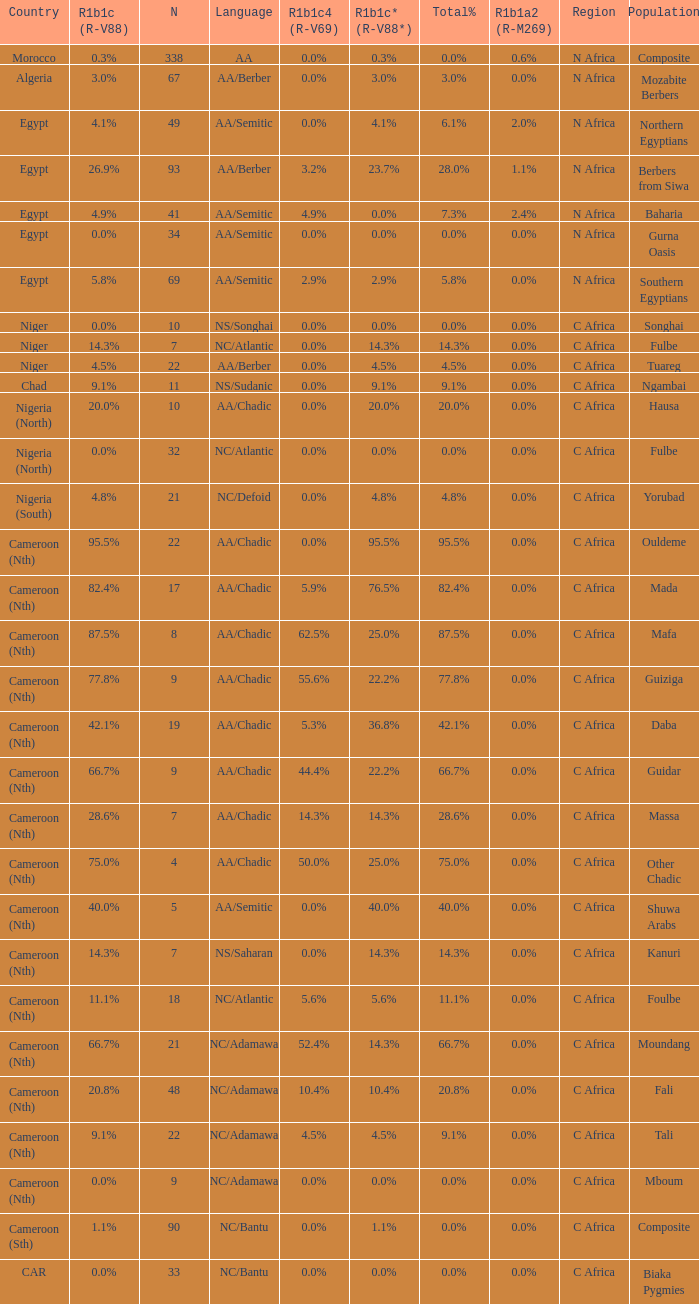How many n are listed for berbers from siwa? 1.0. 